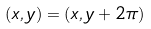Convert formula to latex. <formula><loc_0><loc_0><loc_500><loc_500>( x , y ) = ( x , y + 2 \pi )</formula> 